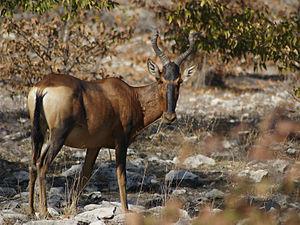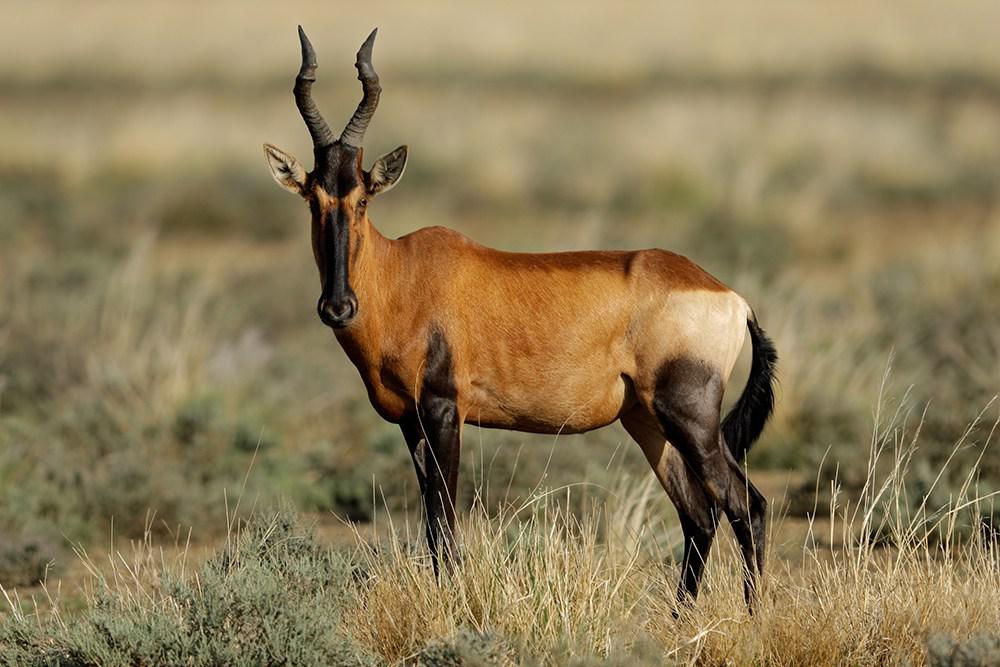The first image is the image on the left, the second image is the image on the right. For the images displayed, is the sentence "Only two antelope-type animals are shown, in total." factually correct? Answer yes or no. Yes. 